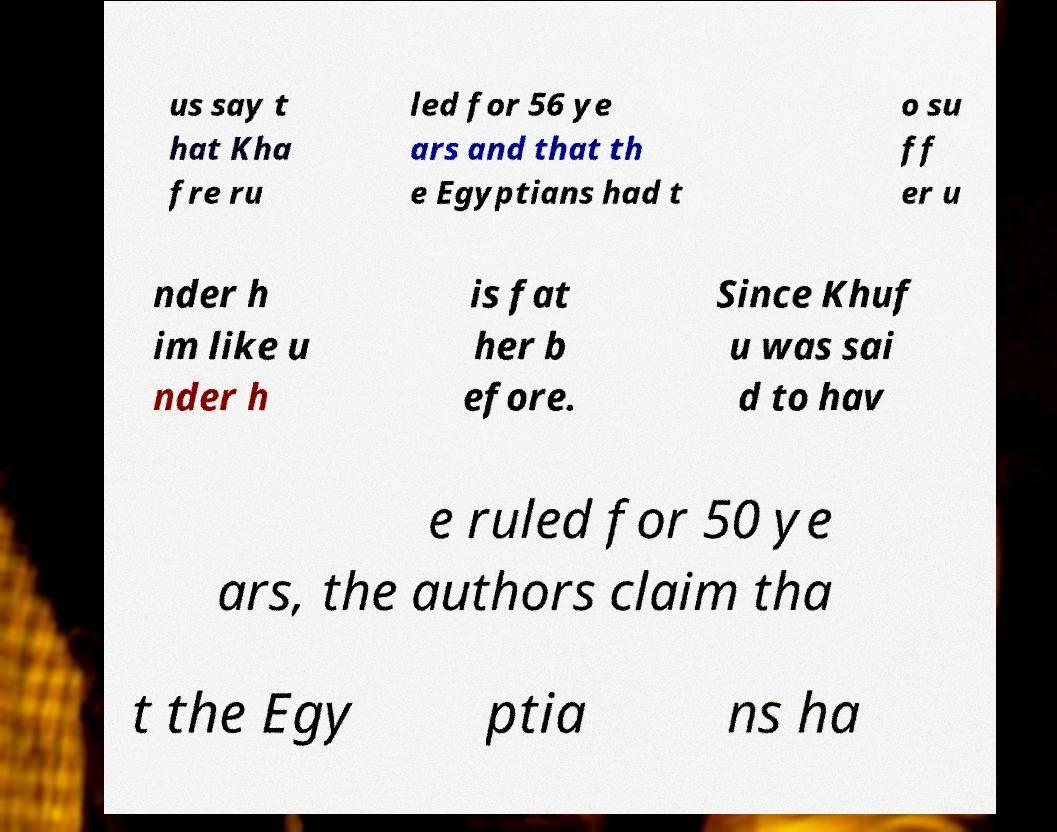Can you read and provide the text displayed in the image?This photo seems to have some interesting text. Can you extract and type it out for me? us say t hat Kha fre ru led for 56 ye ars and that th e Egyptians had t o su ff er u nder h im like u nder h is fat her b efore. Since Khuf u was sai d to hav e ruled for 50 ye ars, the authors claim tha t the Egy ptia ns ha 